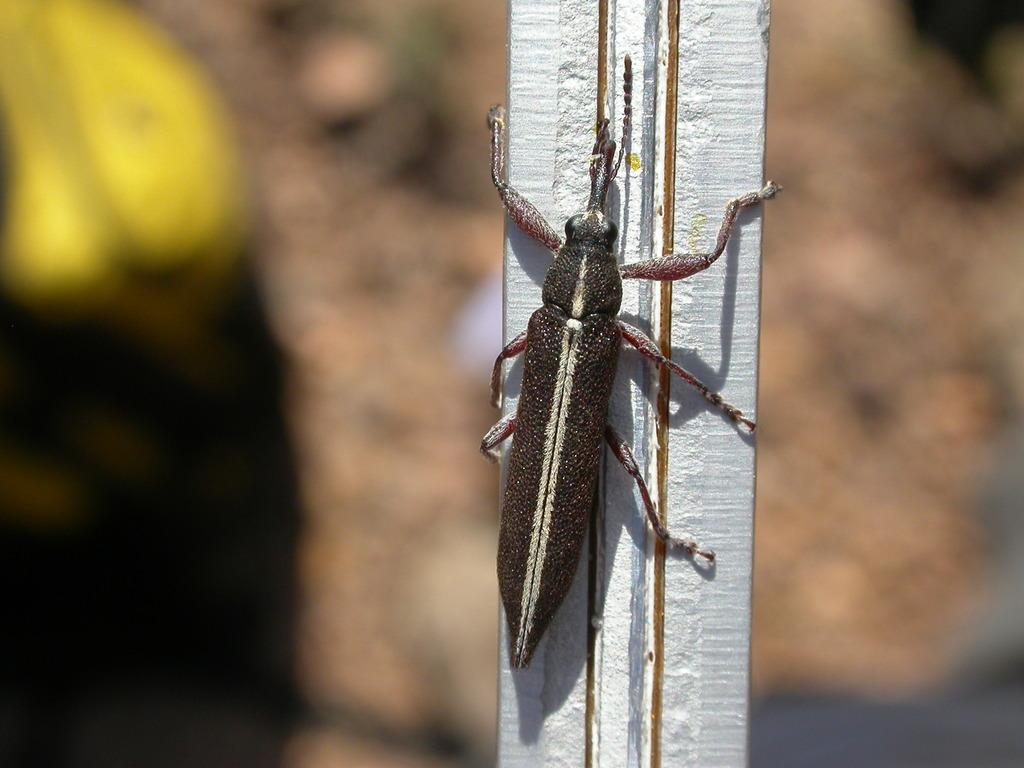What is located on the pillar in the foreground of the image? There is an insect on a pillar in the foreground of the image. What can be seen in the background of the image? There is a rock in the background of the image. When was the image taken? The image was taken during the day. What type of agreement was reached between the yaks in the image? There are no yaks present in the image, so no agreement can be reached between them. 